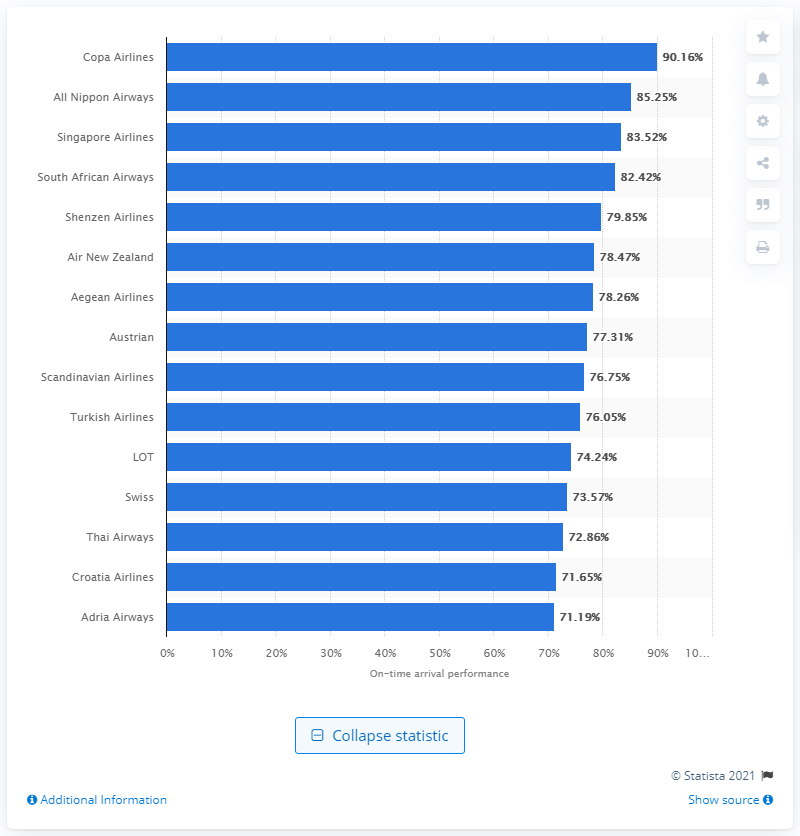Outline some significant characteristics in this image. In 2018, Copa Airlines was ranked as the most punctual airline. 